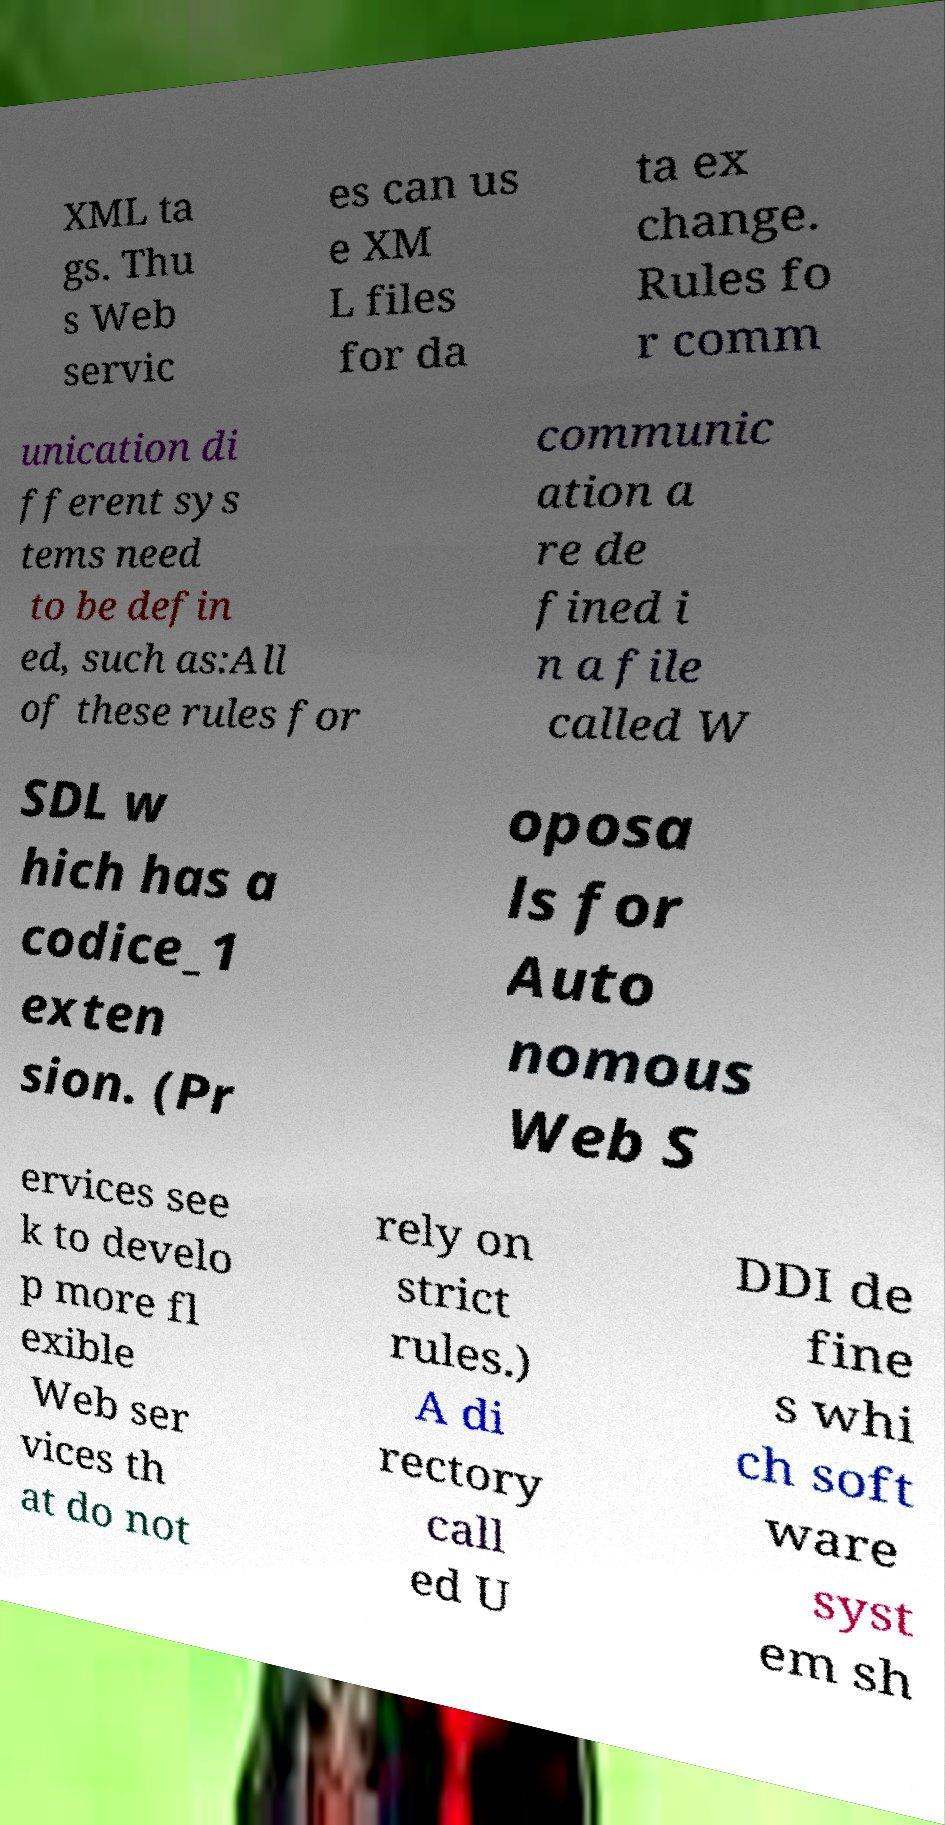What messages or text are displayed in this image? I need them in a readable, typed format. XML ta gs. Thu s Web servic es can us e XM L files for da ta ex change. Rules fo r comm unication di fferent sys tems need to be defin ed, such as:All of these rules for communic ation a re de fined i n a file called W SDL w hich has a codice_1 exten sion. (Pr oposa ls for Auto nomous Web S ervices see k to develo p more fl exible Web ser vices th at do not rely on strict rules.) A di rectory call ed U DDI de fine s whi ch soft ware syst em sh 